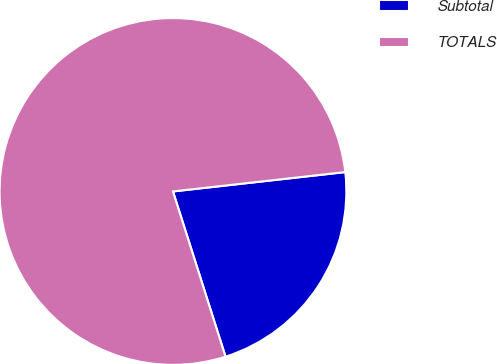Convert chart. <chart><loc_0><loc_0><loc_500><loc_500><pie_chart><fcel>Subtotal<fcel>TOTALS<nl><fcel>21.88%<fcel>78.12%<nl></chart> 